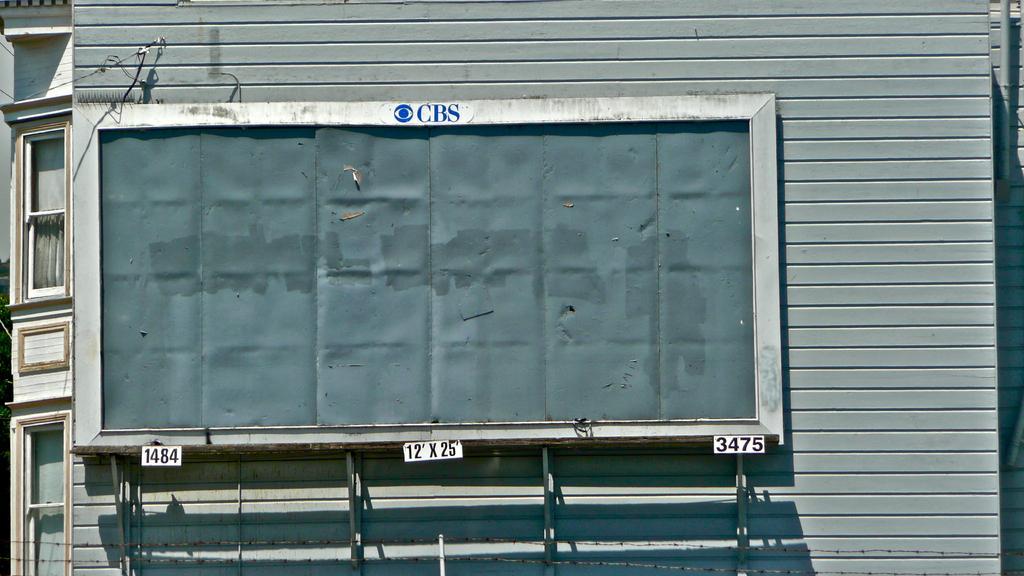In one or two sentences, can you explain what this image depicts? In this image there are windows on the left corner. There are objects on the right corner. There is an object in the foreground. It looks like a wall in the background. 